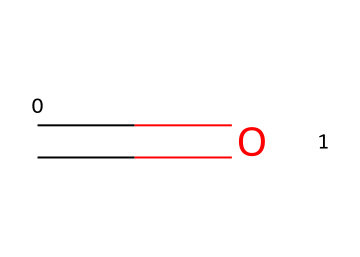What is the chemical name of the structure represented? The SMILES representation indicates the presence of a carbon atom double-bonded to an oxygen atom, which is characteristic of aldehydes. Thus, the name is formaldehyde.
Answer: formaldehyde How many carbon atoms are in the structure? The SMILES notation shows one carbon atom represented by 'C'. Therefore, there is one carbon atom in the structure.
Answer: one What functional group is present in this compound? The presence of a carbonyl group (C=O) in this structure indicates that it belongs to the aldehyde functional group, which is a distinctive feature of aldehydes.
Answer: aldehyde Is this chemical considered hazardous? Formaldehyde is classified as hazardous due to its toxicity and potential carcinogenicity. Hence, it is indeed considered hazardous.
Answer: yes What type of bonding is seen in this structure? The structure shows a double bond (indicated by '=' in SMILES) between carbon and oxygen, which highlights covalent bonding where atoms share electrons.
Answer: covalent What is the common use of this chemical in vintage vinyl production? Formaldehyde is used as a cross-linking agent and a preservative in various materials, including in the production of vintage vinyl records, to enhance durability.
Answer: preservative 